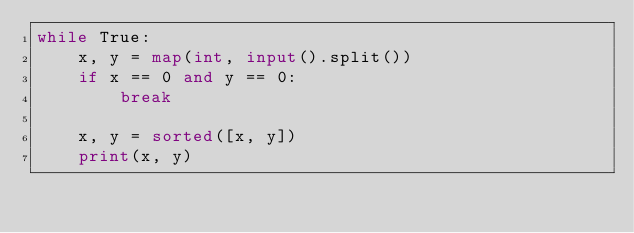<code> <loc_0><loc_0><loc_500><loc_500><_Python_>while True:
    x, y = map(int, input().split())
    if x == 0 and y == 0:
        break

    x, y = sorted([x, y])
    print(x, y)

</code> 